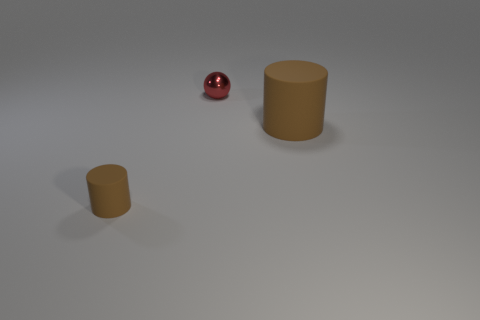Subtract all blue cylinders. Subtract all yellow balls. How many cylinders are left? 2 Add 1 large matte things. How many objects exist? 4 Subtract all balls. How many objects are left? 2 Subtract all tiny red metallic things. Subtract all red metallic balls. How many objects are left? 1 Add 3 red things. How many red things are left? 4 Add 3 small blue rubber cylinders. How many small blue rubber cylinders exist? 3 Subtract 0 cyan blocks. How many objects are left? 3 